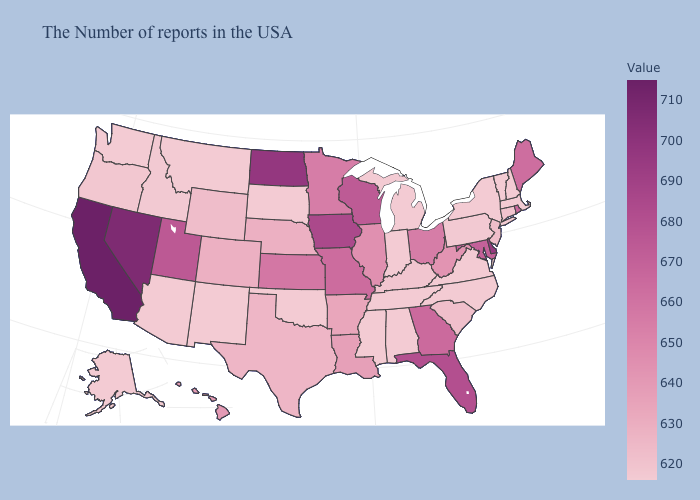Among the states that border Virginia , which have the highest value?
Answer briefly. Maryland. Does the map have missing data?
Write a very short answer. No. Does Michigan have the highest value in the MidWest?
Be succinct. No. Among the states that border Rhode Island , does Massachusetts have the highest value?
Quick response, please. No. Does North Dakota have the highest value in the MidWest?
Give a very brief answer. Yes. Among the states that border Michigan , does Indiana have the lowest value?
Concise answer only. Yes. Does Ohio have a higher value than South Carolina?
Answer briefly. Yes. 